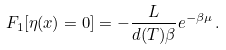<formula> <loc_0><loc_0><loc_500><loc_500>F _ { 1 } [ \eta ( x ) = 0 ] = - \frac { L } { d ( T ) \beta } e ^ { - \beta \mu } \, .</formula> 